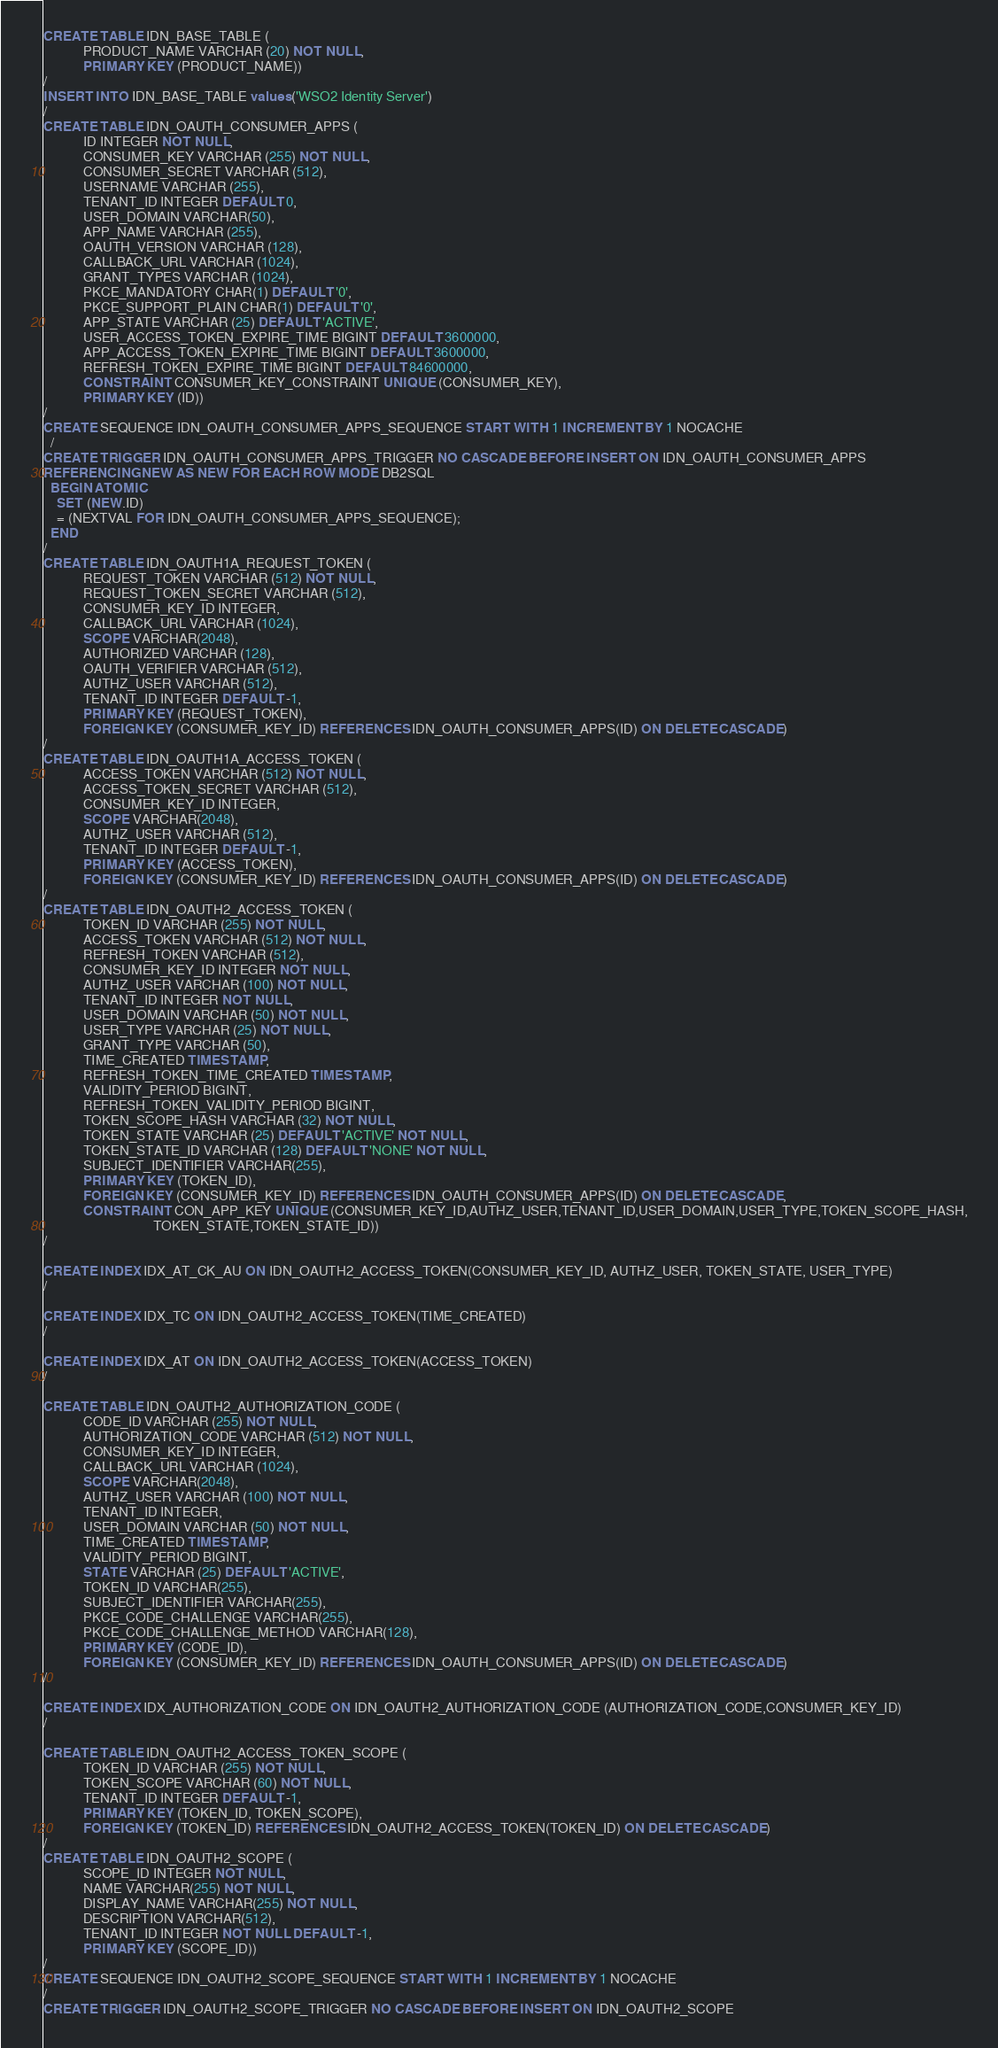<code> <loc_0><loc_0><loc_500><loc_500><_SQL_>CREATE TABLE IDN_BASE_TABLE (
            PRODUCT_NAME VARCHAR (20) NOT NULL,
            PRIMARY KEY (PRODUCT_NAME))
/
INSERT INTO IDN_BASE_TABLE values ('WSO2 Identity Server')
/
CREATE TABLE IDN_OAUTH_CONSUMER_APPS (
            ID INTEGER NOT NULL,
            CONSUMER_KEY VARCHAR (255) NOT NULL,
            CONSUMER_SECRET VARCHAR (512),
            USERNAME VARCHAR (255),
            TENANT_ID INTEGER DEFAULT 0,
            USER_DOMAIN VARCHAR(50),
            APP_NAME VARCHAR (255),
            OAUTH_VERSION VARCHAR (128),
            CALLBACK_URL VARCHAR (1024),
            GRANT_TYPES VARCHAR (1024),
            PKCE_MANDATORY CHAR(1) DEFAULT '0',
            PKCE_SUPPORT_PLAIN CHAR(1) DEFAULT '0',
            APP_STATE VARCHAR (25) DEFAULT 'ACTIVE',
            USER_ACCESS_TOKEN_EXPIRE_TIME BIGINT DEFAULT 3600000,
            APP_ACCESS_TOKEN_EXPIRE_TIME BIGINT DEFAULT 3600000,
            REFRESH_TOKEN_EXPIRE_TIME BIGINT DEFAULT 84600000,
            CONSTRAINT CONSUMER_KEY_CONSTRAINT UNIQUE (CONSUMER_KEY),
            PRIMARY KEY (ID))
/
CREATE SEQUENCE IDN_OAUTH_CONSUMER_APPS_SEQUENCE START WITH 1 INCREMENT BY 1 NOCACHE
  /
CREATE TRIGGER IDN_OAUTH_CONSUMER_APPS_TRIGGER NO CASCADE BEFORE INSERT ON IDN_OAUTH_CONSUMER_APPS
REFERENCING NEW AS NEW FOR EACH ROW MODE DB2SQL
  BEGIN ATOMIC
    SET (NEW.ID)
    = (NEXTVAL FOR IDN_OAUTH_CONSUMER_APPS_SEQUENCE);
  END
/
CREATE TABLE IDN_OAUTH1A_REQUEST_TOKEN (
            REQUEST_TOKEN VARCHAR (512) NOT NULL,
            REQUEST_TOKEN_SECRET VARCHAR (512),
            CONSUMER_KEY_ID INTEGER,
            CALLBACK_URL VARCHAR (1024),
            SCOPE VARCHAR(2048),
            AUTHORIZED VARCHAR (128),
            OAUTH_VERIFIER VARCHAR (512),
            AUTHZ_USER VARCHAR (512),
            TENANT_ID INTEGER DEFAULT -1,
            PRIMARY KEY (REQUEST_TOKEN),
            FOREIGN KEY (CONSUMER_KEY_ID) REFERENCES IDN_OAUTH_CONSUMER_APPS(ID) ON DELETE CASCADE)
/
CREATE TABLE IDN_OAUTH1A_ACCESS_TOKEN (
            ACCESS_TOKEN VARCHAR (512) NOT NULL,
            ACCESS_TOKEN_SECRET VARCHAR (512),
            CONSUMER_KEY_ID INTEGER,
            SCOPE VARCHAR(2048),
            AUTHZ_USER VARCHAR (512),
            TENANT_ID INTEGER DEFAULT -1,
            PRIMARY KEY (ACCESS_TOKEN),
            FOREIGN KEY (CONSUMER_KEY_ID) REFERENCES IDN_OAUTH_CONSUMER_APPS(ID) ON DELETE CASCADE)
/
CREATE TABLE IDN_OAUTH2_ACCESS_TOKEN (
            TOKEN_ID VARCHAR (255) NOT NULL,
            ACCESS_TOKEN VARCHAR (512) NOT NULL,
            REFRESH_TOKEN VARCHAR (512),
            CONSUMER_KEY_ID INTEGER NOT NULL,
            AUTHZ_USER VARCHAR (100) NOT NULL,
            TENANT_ID INTEGER NOT NULL,
            USER_DOMAIN VARCHAR (50) NOT NULL,
            USER_TYPE VARCHAR (25) NOT NULL,
            GRANT_TYPE VARCHAR (50),
            TIME_CREATED TIMESTAMP,
            REFRESH_TOKEN_TIME_CREATED TIMESTAMP,
            VALIDITY_PERIOD BIGINT,
            REFRESH_TOKEN_VALIDITY_PERIOD BIGINT,
            TOKEN_SCOPE_HASH VARCHAR (32) NOT NULL,
            TOKEN_STATE VARCHAR (25) DEFAULT 'ACTIVE' NOT NULL,
            TOKEN_STATE_ID VARCHAR (128) DEFAULT 'NONE' NOT NULL,
            SUBJECT_IDENTIFIER VARCHAR(255),
            PRIMARY KEY (TOKEN_ID),
            FOREIGN KEY (CONSUMER_KEY_ID) REFERENCES IDN_OAUTH_CONSUMER_APPS(ID) ON DELETE CASCADE,
            CONSTRAINT CON_APP_KEY UNIQUE (CONSUMER_KEY_ID,AUTHZ_USER,TENANT_ID,USER_DOMAIN,USER_TYPE,TOKEN_SCOPE_HASH,
                                 TOKEN_STATE,TOKEN_STATE_ID))
/

CREATE INDEX IDX_AT_CK_AU ON IDN_OAUTH2_ACCESS_TOKEN(CONSUMER_KEY_ID, AUTHZ_USER, TOKEN_STATE, USER_TYPE)
/

CREATE INDEX IDX_TC ON IDN_OAUTH2_ACCESS_TOKEN(TIME_CREATED)
/

CREATE INDEX IDX_AT ON IDN_OAUTH2_ACCESS_TOKEN(ACCESS_TOKEN)
/

CREATE TABLE IDN_OAUTH2_AUTHORIZATION_CODE (
            CODE_ID VARCHAR (255) NOT NULL,
            AUTHORIZATION_CODE VARCHAR (512) NOT NULL,
            CONSUMER_KEY_ID INTEGER,
            CALLBACK_URL VARCHAR (1024),
            SCOPE VARCHAR(2048),
            AUTHZ_USER VARCHAR (100) NOT NULL,
            TENANT_ID INTEGER,
            USER_DOMAIN VARCHAR (50) NOT NULL,
            TIME_CREATED TIMESTAMP,
            VALIDITY_PERIOD BIGINT,
            STATE VARCHAR (25) DEFAULT 'ACTIVE',
            TOKEN_ID VARCHAR(255),
            SUBJECT_IDENTIFIER VARCHAR(255),
            PKCE_CODE_CHALLENGE VARCHAR(255),
            PKCE_CODE_CHALLENGE_METHOD VARCHAR(128),
            PRIMARY KEY (CODE_ID),
            FOREIGN KEY (CONSUMER_KEY_ID) REFERENCES IDN_OAUTH_CONSUMER_APPS(ID) ON DELETE CASCADE)
/

CREATE INDEX IDX_AUTHORIZATION_CODE ON IDN_OAUTH2_AUTHORIZATION_CODE (AUTHORIZATION_CODE,CONSUMER_KEY_ID)
/

CREATE TABLE IDN_OAUTH2_ACCESS_TOKEN_SCOPE (
            TOKEN_ID VARCHAR (255) NOT NULL,
            TOKEN_SCOPE VARCHAR (60) NOT NULL,
            TENANT_ID INTEGER DEFAULT -1,
            PRIMARY KEY (TOKEN_ID, TOKEN_SCOPE),
            FOREIGN KEY (TOKEN_ID) REFERENCES IDN_OAUTH2_ACCESS_TOKEN(TOKEN_ID) ON DELETE CASCADE)
/
CREATE TABLE IDN_OAUTH2_SCOPE (
            SCOPE_ID INTEGER NOT NULL,
            NAME VARCHAR(255) NOT NULL,
            DISPLAY_NAME VARCHAR(255) NOT NULL,
            DESCRIPTION VARCHAR(512),
            TENANT_ID INTEGER NOT NULL DEFAULT -1,
            PRIMARY KEY (SCOPE_ID))
/
CREATE SEQUENCE IDN_OAUTH2_SCOPE_SEQUENCE START WITH 1 INCREMENT BY 1 NOCACHE
/
CREATE TRIGGER IDN_OAUTH2_SCOPE_TRIGGER NO CASCADE BEFORE INSERT ON IDN_OAUTH2_SCOPE</code> 